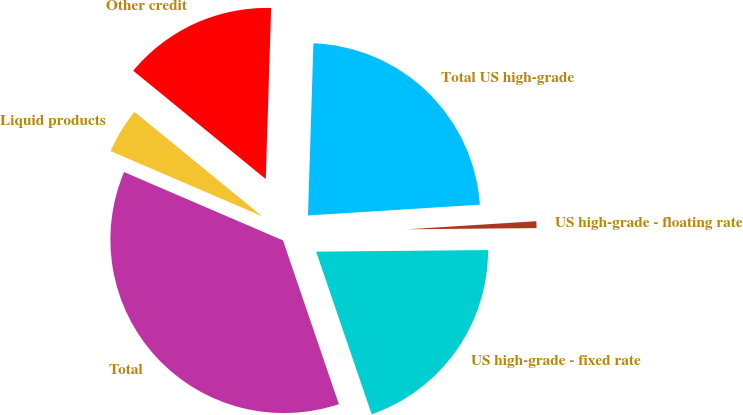Convert chart to OTSL. <chart><loc_0><loc_0><loc_500><loc_500><pie_chart><fcel>US high-grade - fixed rate<fcel>US high-grade - floating rate<fcel>Total US high-grade<fcel>Other credit<fcel>Liquid products<fcel>Total<nl><fcel>19.91%<fcel>0.85%<fcel>23.5%<fcel>14.6%<fcel>4.44%<fcel>36.7%<nl></chart> 